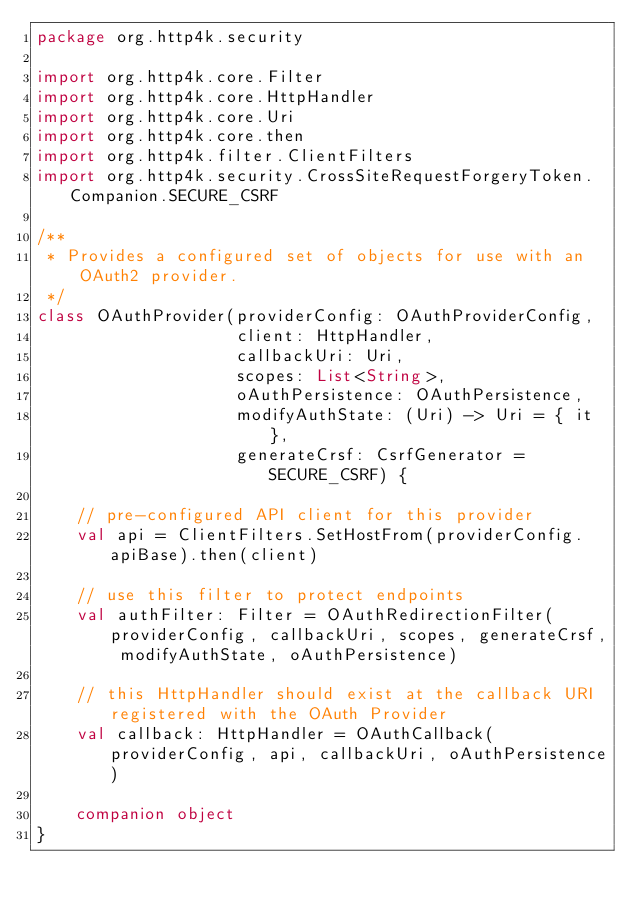<code> <loc_0><loc_0><loc_500><loc_500><_Kotlin_>package org.http4k.security

import org.http4k.core.Filter
import org.http4k.core.HttpHandler
import org.http4k.core.Uri
import org.http4k.core.then
import org.http4k.filter.ClientFilters
import org.http4k.security.CrossSiteRequestForgeryToken.Companion.SECURE_CSRF

/**
 * Provides a configured set of objects for use with an OAuth2 provider.
 */
class OAuthProvider(providerConfig: OAuthProviderConfig,
                    client: HttpHandler,
                    callbackUri: Uri,
                    scopes: List<String>,
                    oAuthPersistence: OAuthPersistence,
                    modifyAuthState: (Uri) -> Uri = { it },
                    generateCrsf: CsrfGenerator = SECURE_CSRF) {

    // pre-configured API client for this provider
    val api = ClientFilters.SetHostFrom(providerConfig.apiBase).then(client)

    // use this filter to protect endpoints
    val authFilter: Filter = OAuthRedirectionFilter(providerConfig, callbackUri, scopes, generateCrsf, modifyAuthState, oAuthPersistence)

    // this HttpHandler should exist at the callback URI registered with the OAuth Provider
    val callback: HttpHandler = OAuthCallback(providerConfig, api, callbackUri, oAuthPersistence)

    companion object
}

</code> 